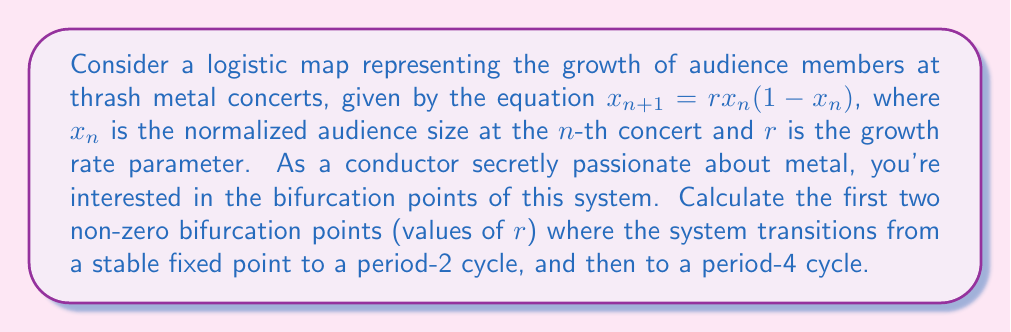Give your solution to this math problem. To find the bifurcation points, we need to analyze the stability of the fixed points and their period-doubling behavior:

1. First, find the non-zero fixed point of the system:
   $x^* = rx^*(1-x^*)$
   $x^* = 1 - \frac{1}{r}$ for $r > 1$

2. The stability of this fixed point is determined by the derivative of the map at $x^*$:
   $f'(x) = r(1-2x)$
   $f'(x^*) = r(1-2(1-\frac{1}{r})) = 2-r$

3. The fixed point loses stability when $|f'(x^*)| = 1$. Solving for $r$:
   $|2-r| = 1$
   $r = 3$ (since $r > 1$)

This is the first bifurcation point, where the system transitions from a stable fixed point to a period-2 cycle.

4. For the second bifurcation (transition to period-4), we need to consider the second iterate of the map:
   $f^2(x) = r^2x(1-x)(1-rx(1-x))$

5. The stability of the period-2 cycle is determined by the derivative of $f^2(x)$ at the cycle points. The cycle loses stability when:
   $|(f^2)'(x)| = 1$ at the cycle points

6. Solving this equation analytically is complex, but numerically we find:
   $r \approx 3.449490...$ (often denoted as $1+\sqrt{6}$)

This is the second bifurcation point, where the system transitions from a period-2 cycle to a period-4 cycle.
Answer: $r_1 = 3$, $r_2 \approx 3.449490$ 